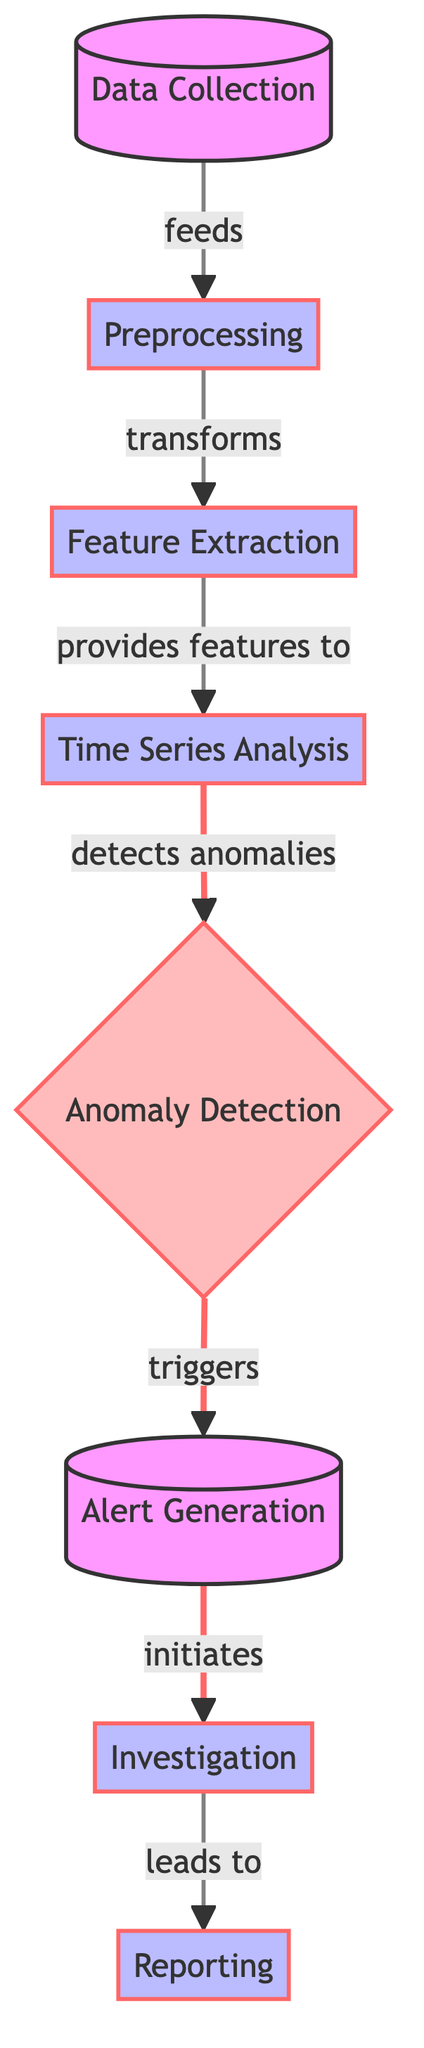What is the first stage in the diagram? The first stage in the diagram is labeled as "Data Collection," which is the starting point of the process where data is gathered.
Answer: Data Collection How many nodes are categorized as processes in the diagram? There are five nodes categorized as processes, including "Preprocessing," "Feature Extraction," "Time Series Analysis," "Investigation," and "Reporting."
Answer: Five What is the relationship between "Time Series Analysis" and "Anomaly Detection"? The relationship is that "Time Series Analysis" provides input for detecting anomalies in the subsequent node.
Answer: Detects anomalies Which node initiates the investigation phase? The "Alert Generation" node initiates the investigation phase as denoted by the arrow that leads from it to "Investigation."
Answer: Alert Generation What triggers alert generation? The anomaly detection process triggers alert generation, as indicated by the directional flow from "Anomaly Detection" to "Alert Generation."
Answer: Anomaly Detection How many connections lead into the "Anomaly Detection" node? There is one connection leading into the "Anomaly Detection" node from "Time Series Analysis," which is the only preceding node.
Answer: One What is the final node of the process flow? The final node of the process flow is "Reporting," which indicates the end of the sequence after all investigations have been completed.
Answer: Reporting Which node is classified as an alert in the diagram? The "Anomaly Detection" node is classified as an alert, highlighted by its distinctive color and bold font in the diagram.
Answer: Anomaly Detection What does the "Preprocessing" node transform? The "Preprocessing" node transforms the data collected in the initial stage, preparing it for the next steps in feature extraction.
Answer: Data How many links have a distinct visual style connecting to the "Anomaly Detection" node? There are three links with a distinct visual style connecting to the "Anomaly Detection" node, which indicates important relationships in the diagram.
Answer: Three 